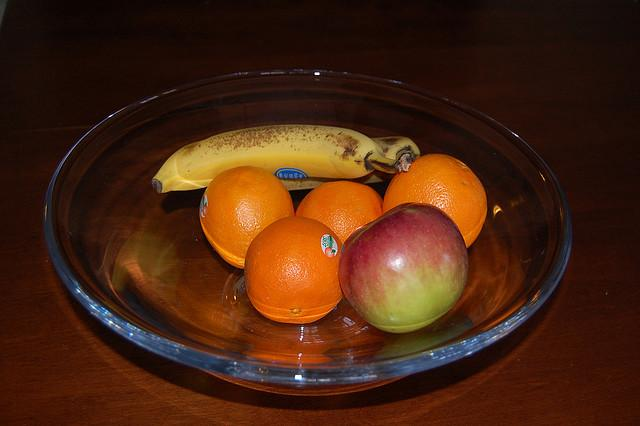What type of fruit is at the front of this fruit basket ahead of all of the oranges? Please explain your reasoning. apple. The fruit is an apple. 